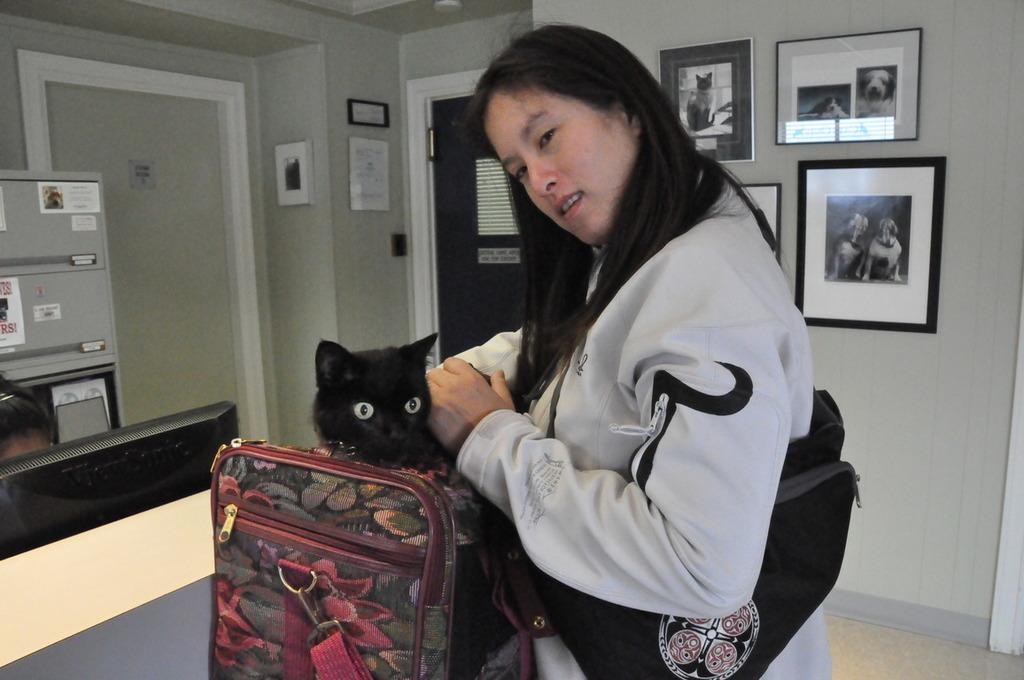Where was the image taken? The image was taken in a room. Who is present in the image? There is a woman in the image. What is the woman holding in the image? The woman is holding a black cat in a bag. What can be seen on the wall in the background? There are photos on the wall in the background. What architectural feature is visible in the background? There is a door in the background. What is the sister's interest in the division of the room? There is no mention of a sister or any division of the room in the image. 